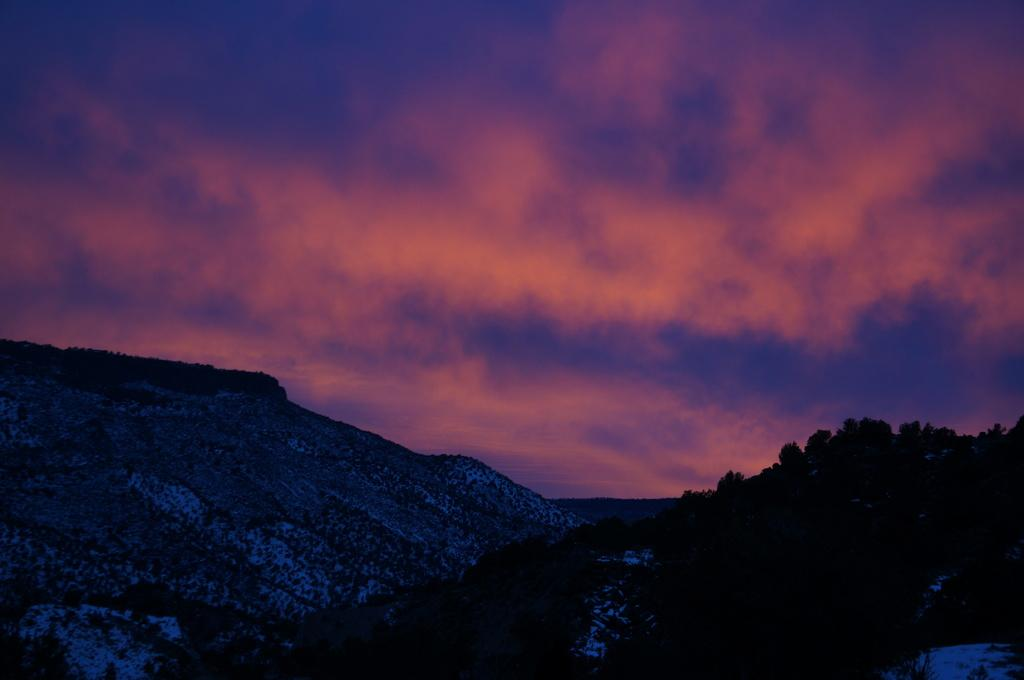What can be seen in the background of the image? The sky is visible in the image. What is present in the sky? There are clouds in the sky. What type of landscape can be observed in the image? There are hills in the image. What type of vegetation is present in the image? Trees are present in the image. Where is the sister standing with her stick in the image? There is no sister or stick present in the image. 